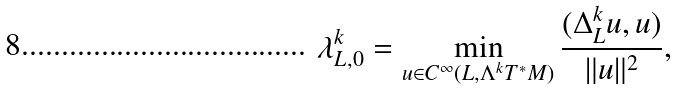Convert formula to latex. <formula><loc_0><loc_0><loc_500><loc_500>\lambda ^ { k } _ { L , 0 } = \min _ { u \in C ^ { \infty } ( L , \Lambda ^ { k } T ^ { * } M ) } \frac { ( \Delta ^ { k } _ { L } u , u ) } { \| u \| ^ { 2 } } ,</formula> 